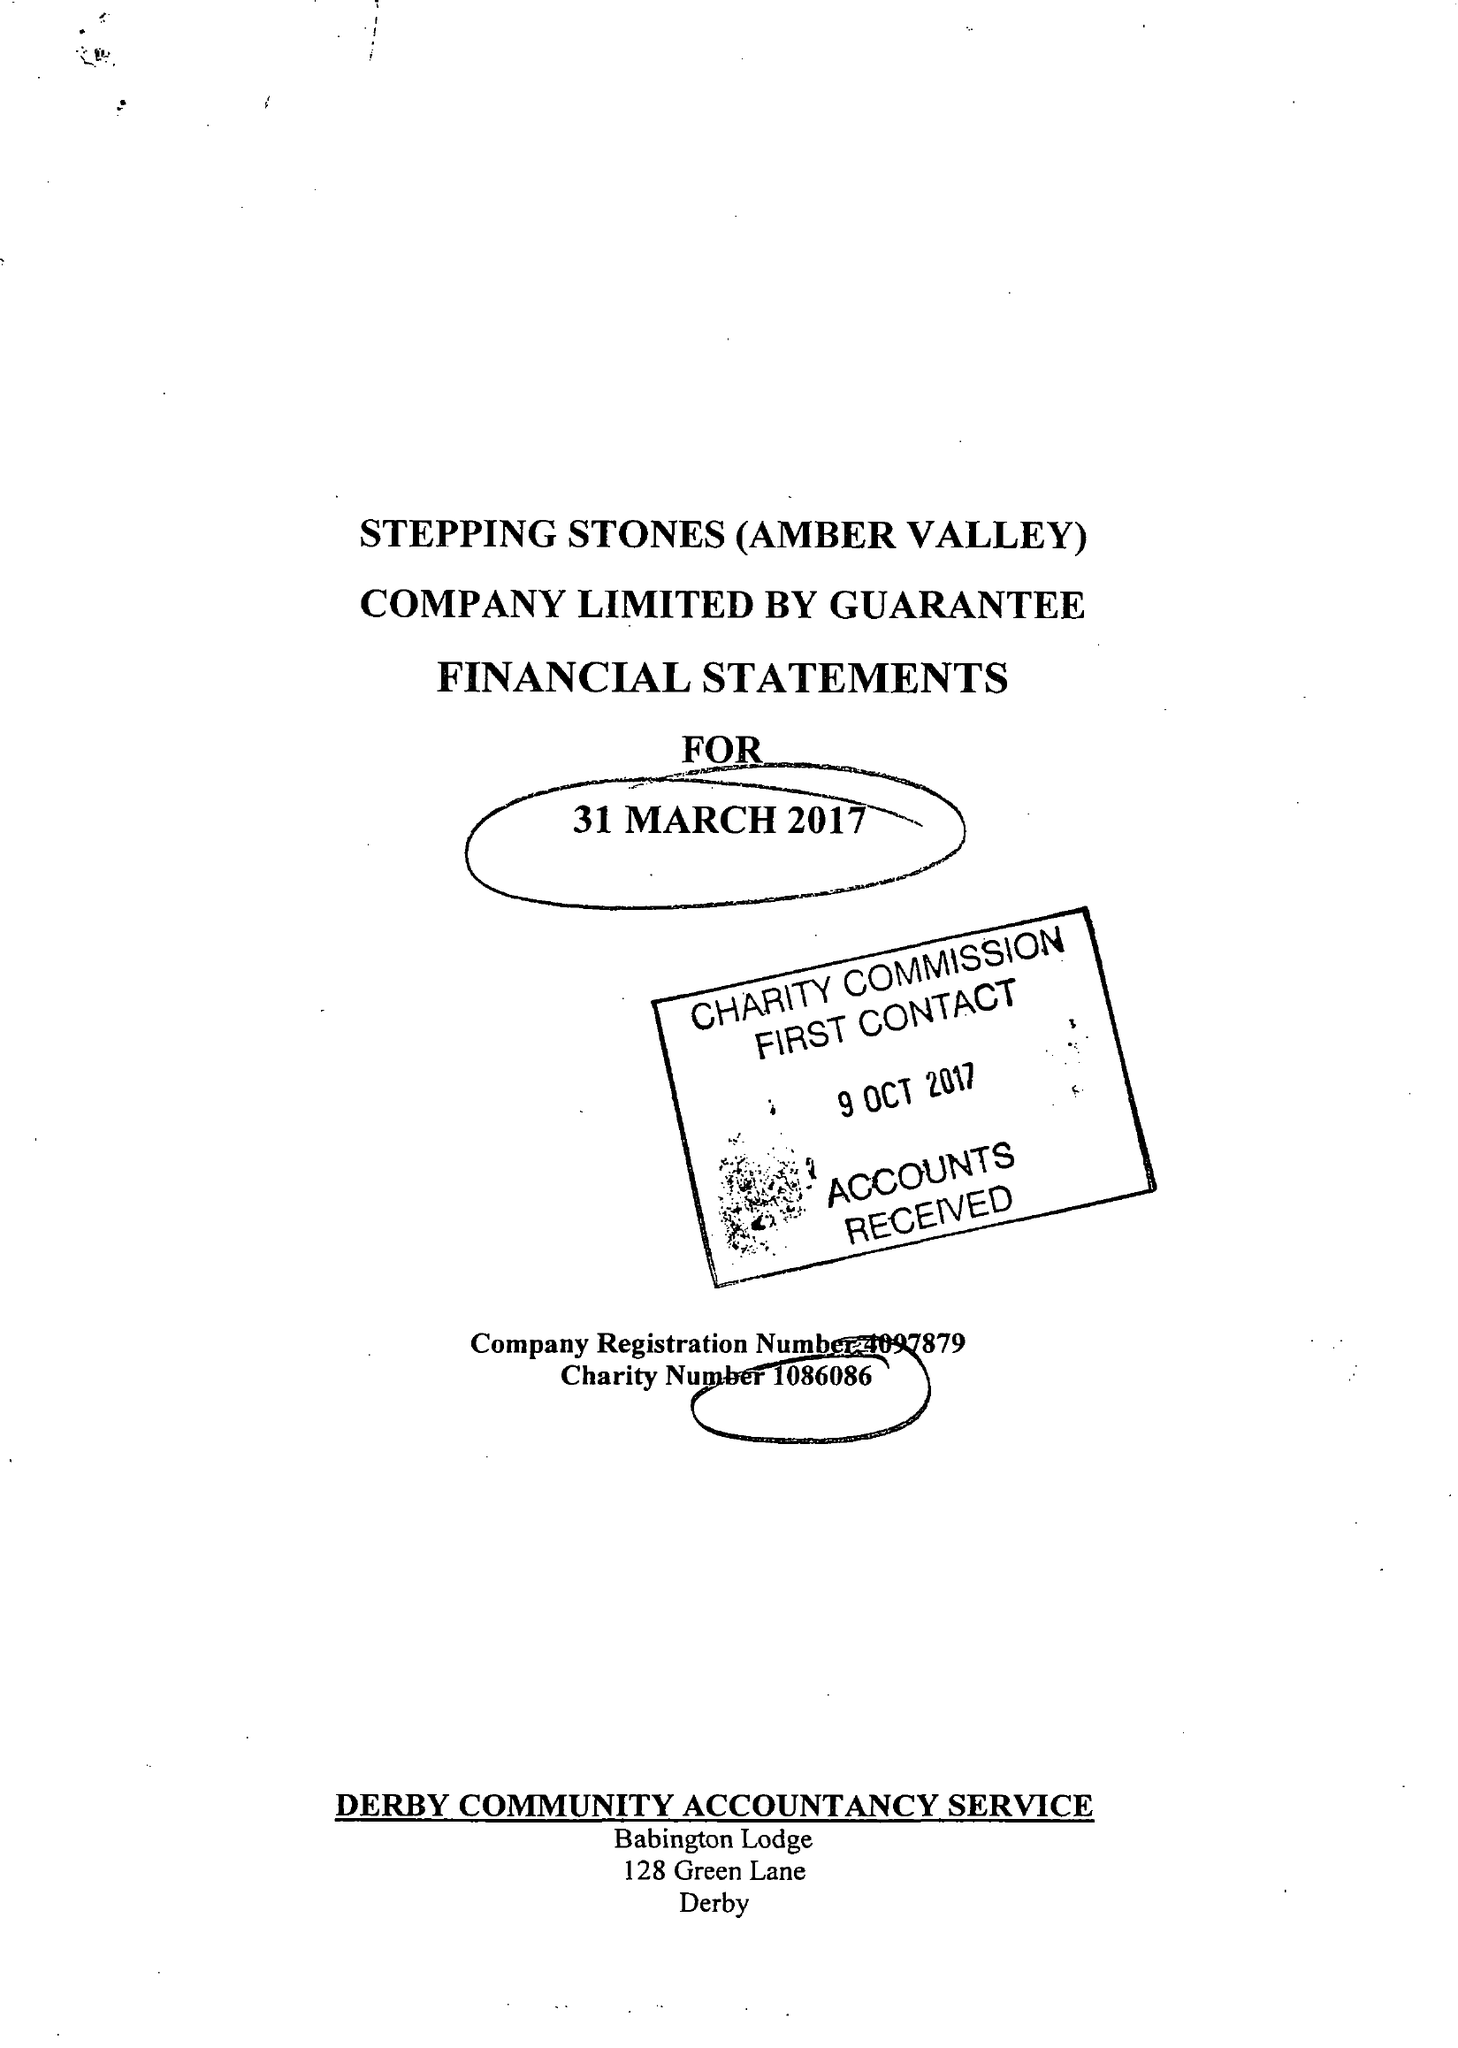What is the value for the address__postcode?
Answer the question using a single word or phrase. NG16 4HG 